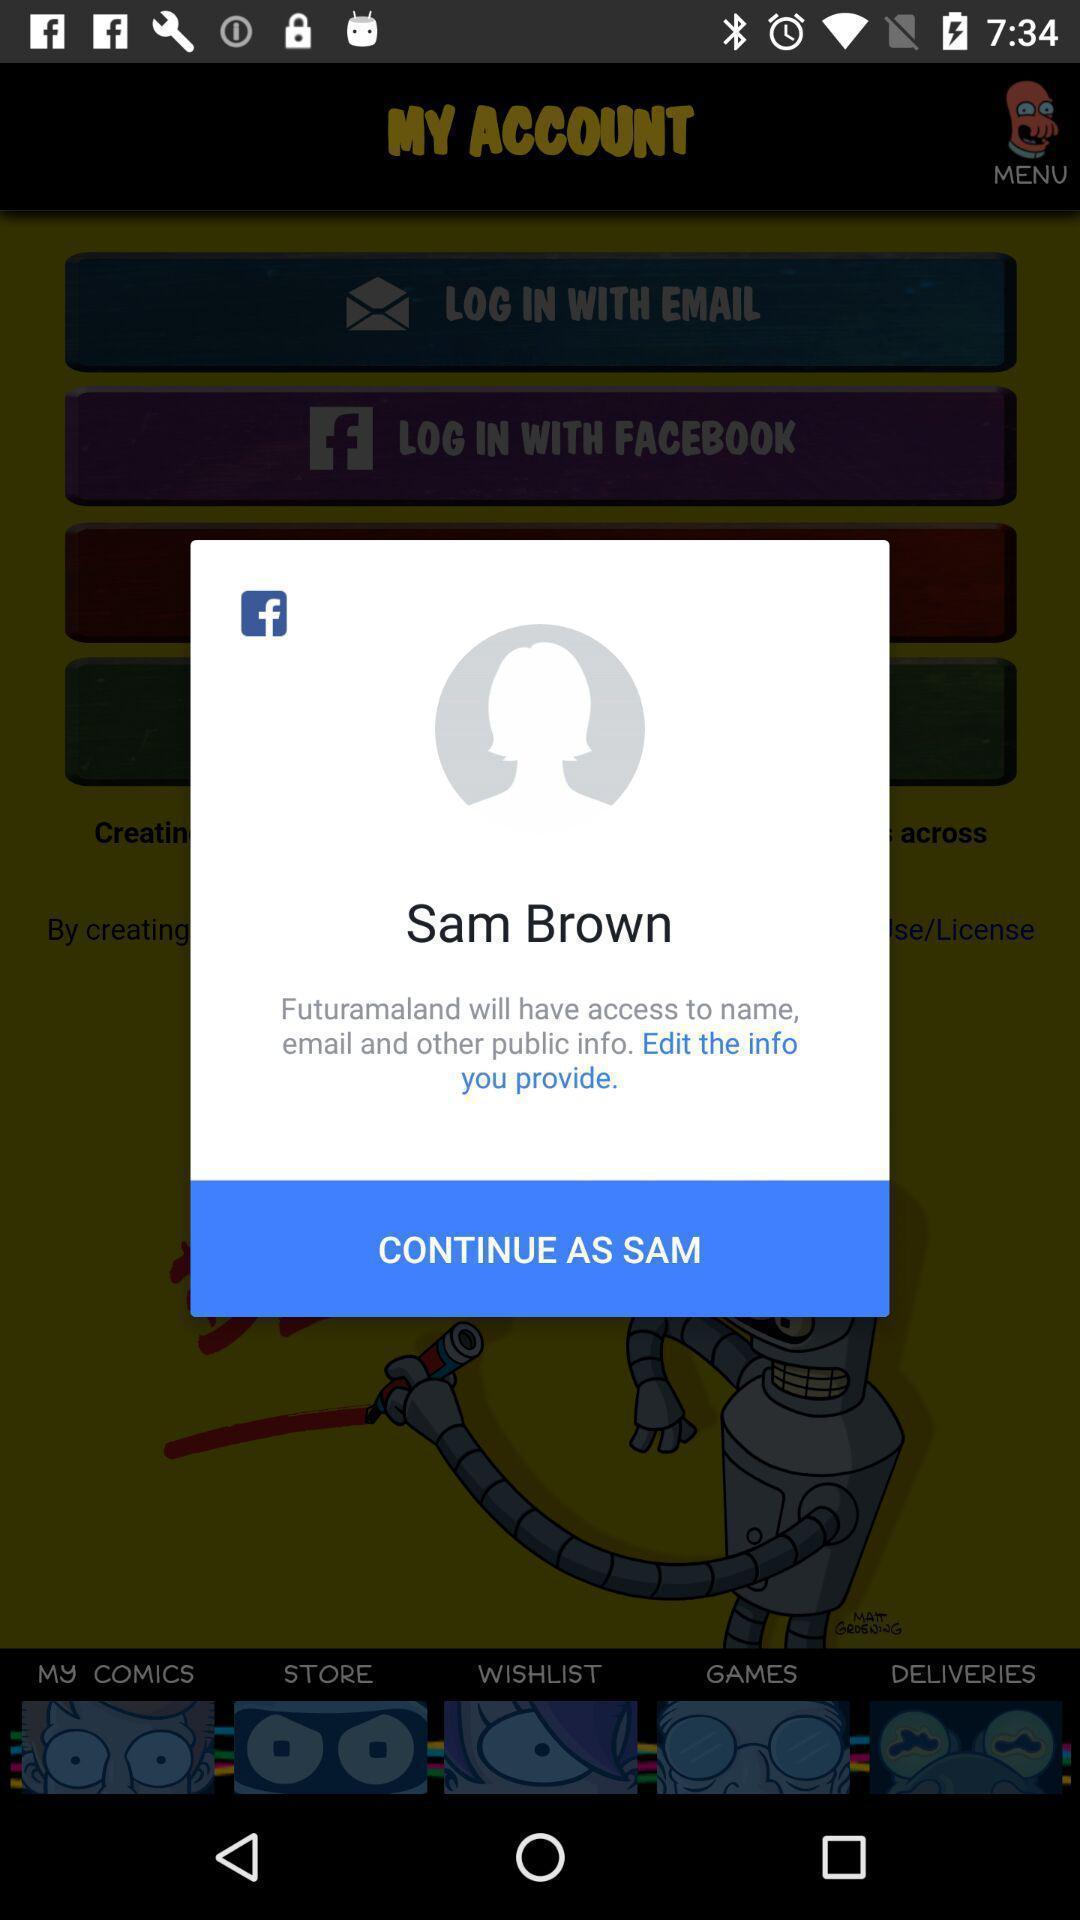Describe this image in words. Pop-up to edit the profile information. 